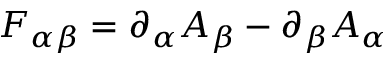Convert formula to latex. <formula><loc_0><loc_0><loc_500><loc_500>F _ { \alpha \beta } = \partial _ { \alpha } A _ { \beta } - \partial _ { \beta } A _ { \alpha }</formula> 